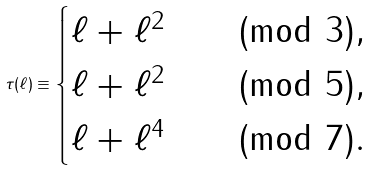<formula> <loc_0><loc_0><loc_500><loc_500>\tau ( \ell ) \equiv \begin{cases} \ell + \ell ^ { 2 } & \pmod { 3 } , \\ \ell + \ell ^ { 2 } & \pmod { 5 } , \\ \ell + \ell ^ { 4 } & \pmod { 7 } . \end{cases}</formula> 